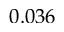<formula> <loc_0><loc_0><loc_500><loc_500>0 . 0 3 6</formula> 